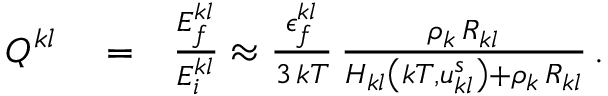<formula> <loc_0><loc_0><loc_500><loc_500>\begin{array} { r l r } { Q ^ { k l } } & = } & { \frac { E _ { f } ^ { k l } } { E _ { i } ^ { k l } } \approx \frac { \epsilon _ { f } ^ { k l } } { 3 \, k T } \, \frac { \rho _ { k } \, R _ { k l } } { H _ { k l } \left ( k T , u _ { k l } ^ { s } \right ) + \rho _ { k } \, R _ { k l } } \, . } \end{array}</formula> 